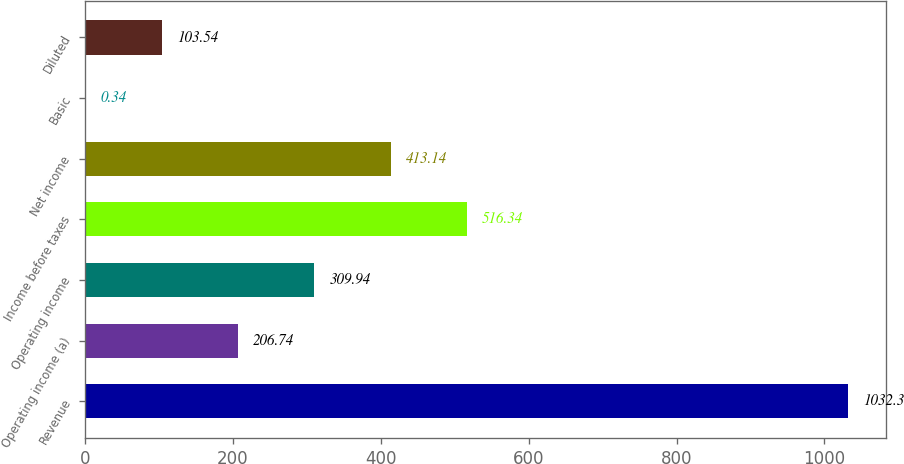Convert chart to OTSL. <chart><loc_0><loc_0><loc_500><loc_500><bar_chart><fcel>Revenue<fcel>Operating income (a)<fcel>Operating income<fcel>Income before taxes<fcel>Net income<fcel>Basic<fcel>Diluted<nl><fcel>1032.3<fcel>206.74<fcel>309.94<fcel>516.34<fcel>413.14<fcel>0.34<fcel>103.54<nl></chart> 